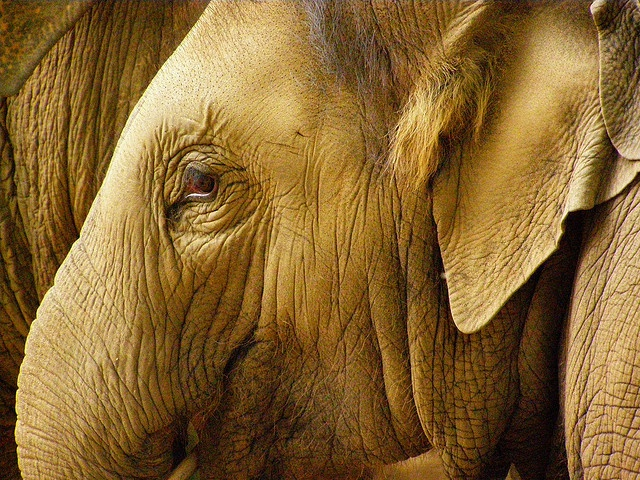Describe the objects in this image and their specific colors. I can see elephant in olive, maroon, and tan tones and elephant in olive, maroon, and black tones in this image. 